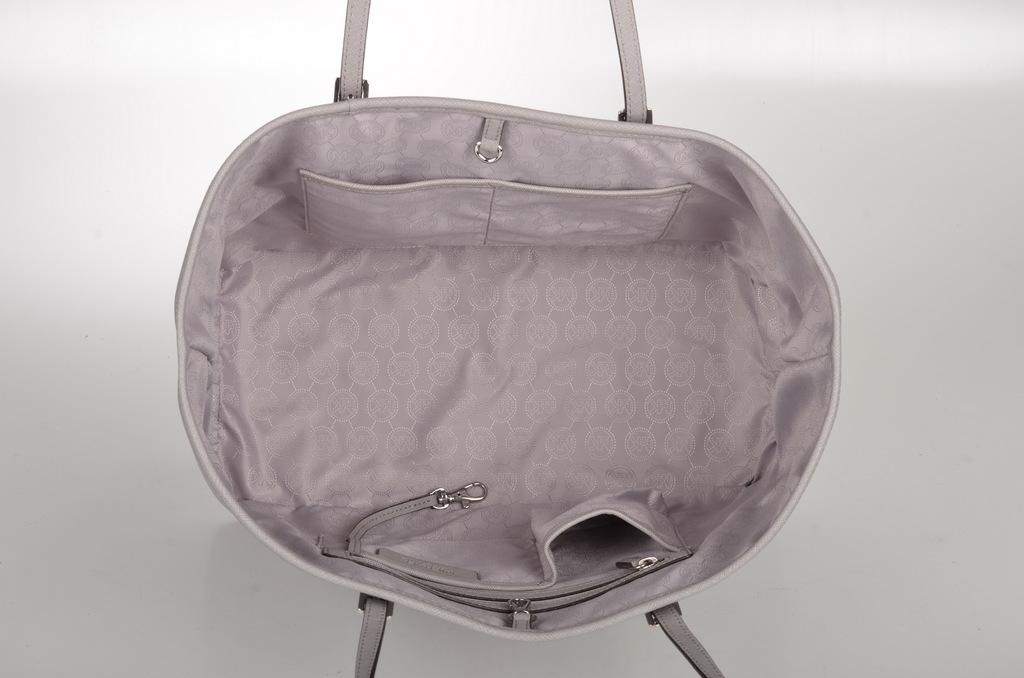What object can be seen in the image? There is a bag in the image. What type of manager is responsible for the planes seen at the edge of the image? There are no planes or edges present in the image, and therefore no manager is mentioned or implied. 